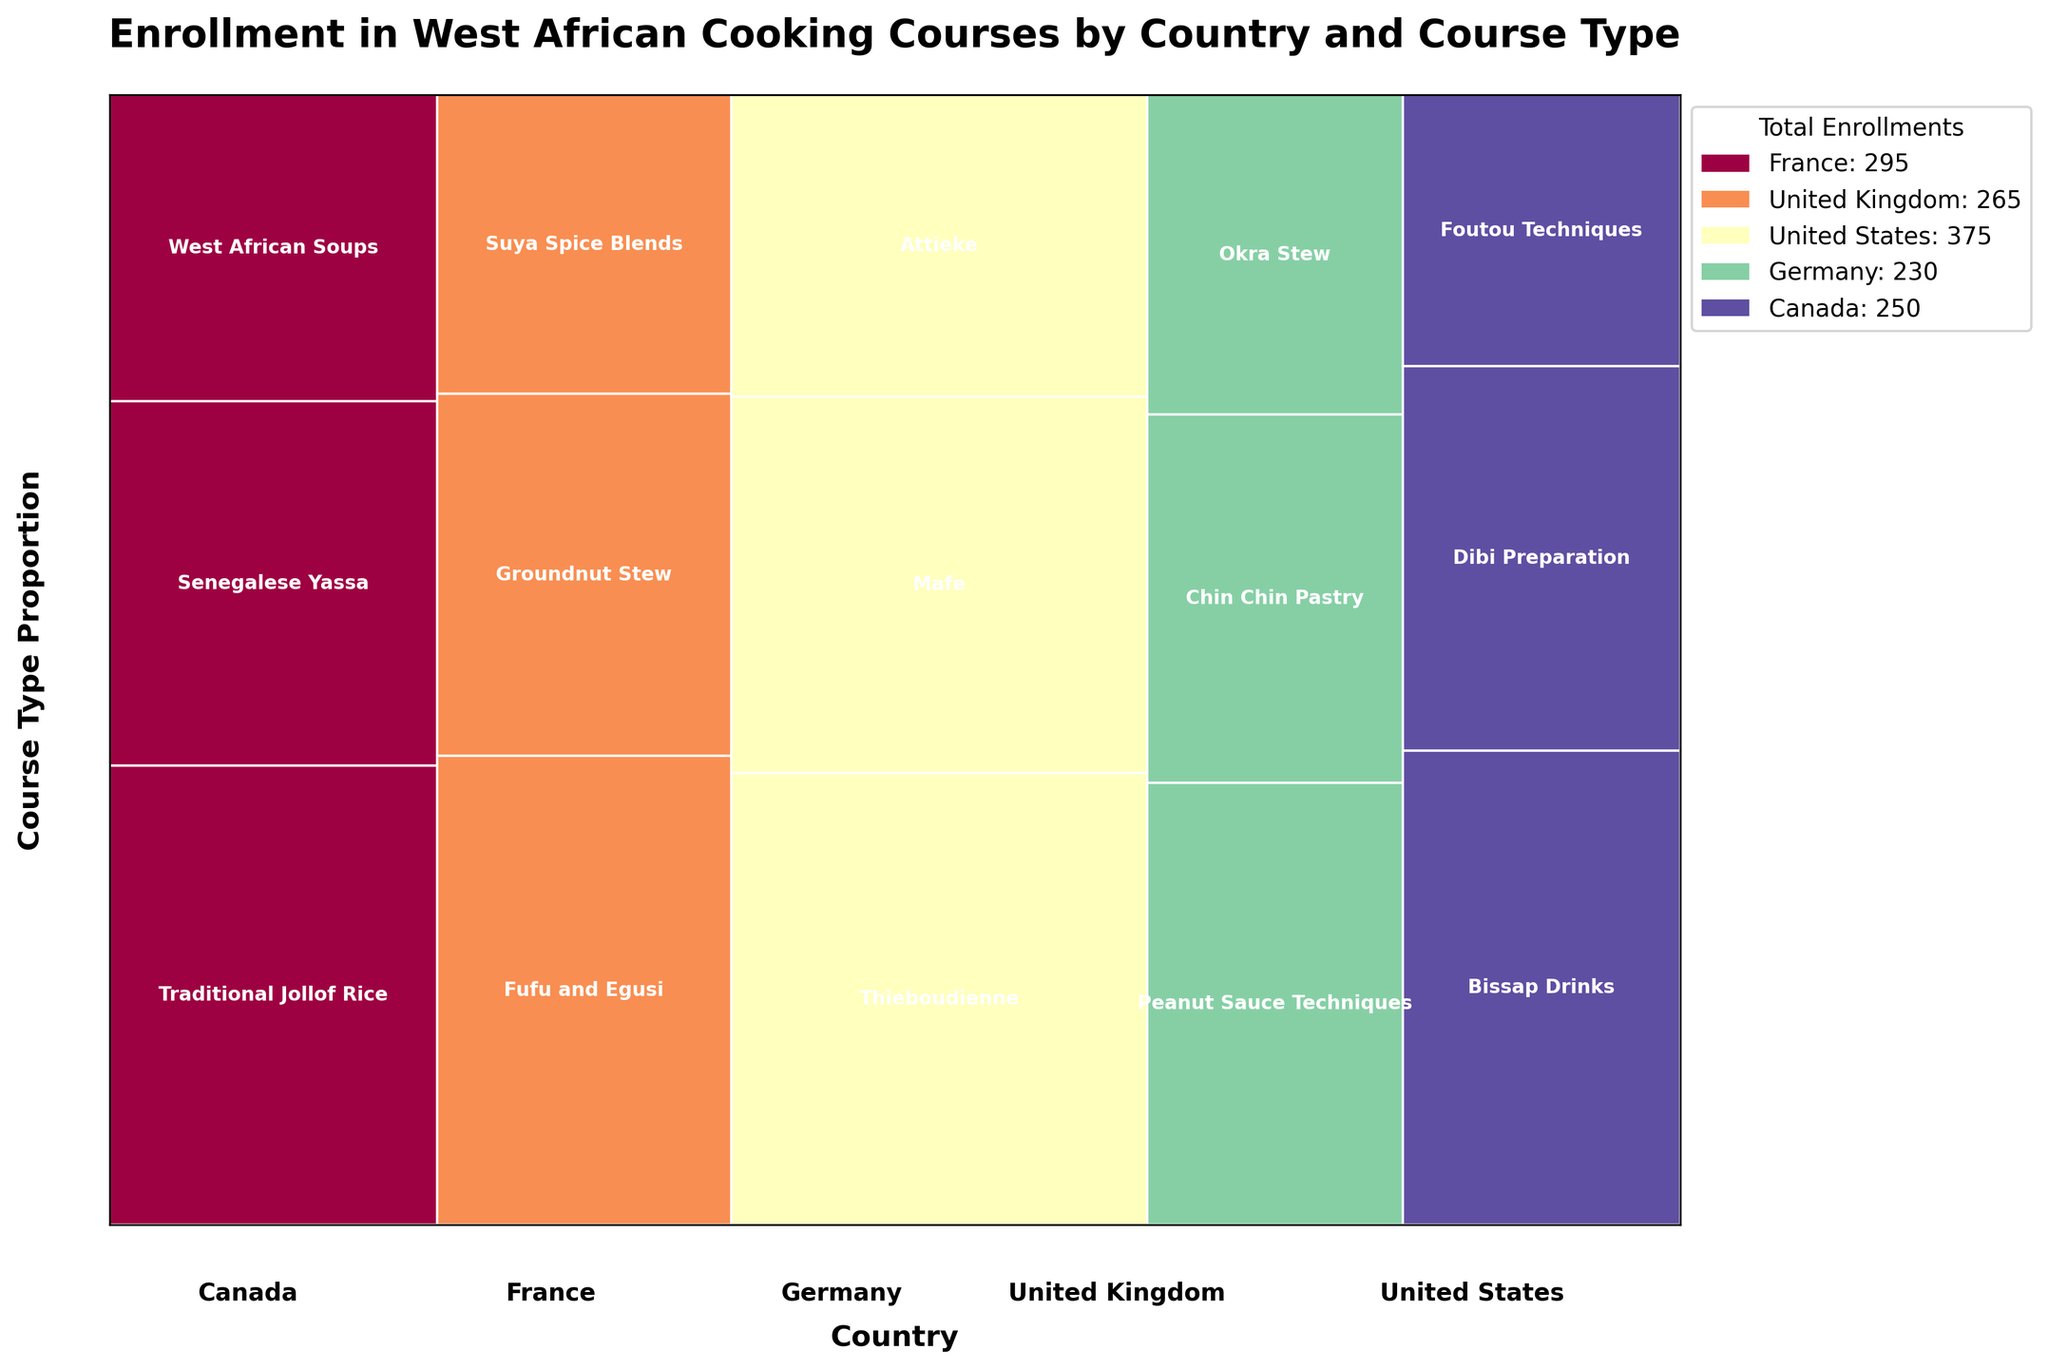What is the title of the plot? Look at the top of the plot where the main heading or title is displayed. The title usually describes the main subject of the plot.
Answer: Enrollment in West African Cooking Courses by Country and Course Type How many countries are represented in the plot? Count the number of unique country names labeled along the x-axis.
Answer: 5 Which country has the highest total enrollment? The total enrollment by country can be inferred by comparing the widths of the blocks on the x-axis. The country with the widest block has the highest total enrollment.
Answer: United States What course type has the highest proportion of enrollments in the United States? Identify the tallest block within the section representing the United States to find the course type with the highest proportion of enrollments.
Answer: Thieboudienne Which country offers the most diverse range of West African cooking courses? Count the number of different course types within each country's block. The country with the highest count offers the most diverse range.
Answer: France (multiple courses including Traditional Jollof Rice, Senegalese Yassa, and West African Soups) Among Germany's offered courses, which has the lowest enrollment proportion? Identify the shortest block within the Germany section to determine the course type with the lowest enrollment proportion.
Answer: Okra Stew How does the total enrollment in Canada compare to that in France? This involves comparing the widths of the blocks for Canada and France to determine which one is wider, indicating higher total enrollment.
Answer: France has a higher total enrollment What proportion of enrollments in the United Kingdom is for 'Groundnut Stew'? Find the height of the 'Groundnut Stew' block within the United Kingdom section and compare it to the total height of the UK section on the plot.
Answer: Approximately 30.4% (85/280 total enrollment in UK) Which country has more enrollments for 'Peanut Sauce Techniques', Germany or France? Locate the sections for Germany and France and find the enrollment proportions for 'Peanut Sauce Techniques'; compare these values directly.
Answer: Germany What course types form the smallest proportion of enrollments in both Canada and Germany? Assess the smallest blocks in both the Canada and Germany sections to identify the course types with the lowest enrollment proportions.
Answer: Foutou Techniques in Canada and Okra Stew in Germany 